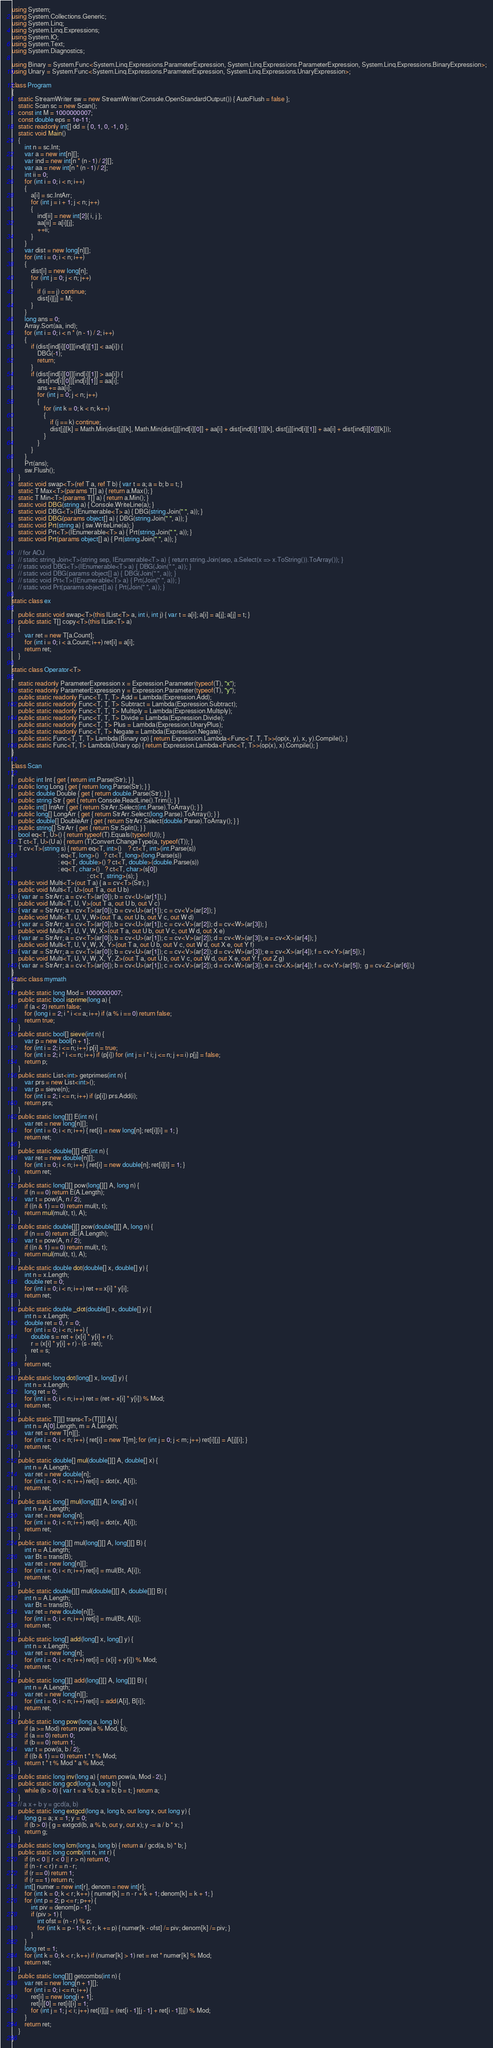<code> <loc_0><loc_0><loc_500><loc_500><_C#_>using System;
using System.Collections.Generic;
using System.Linq;
using System.Linq.Expressions;
using System.IO;
using System.Text;
using System.Diagnostics;

using Binary = System.Func<System.Linq.Expressions.ParameterExpression, System.Linq.Expressions.ParameterExpression, System.Linq.Expressions.BinaryExpression>;
using Unary = System.Func<System.Linq.Expressions.ParameterExpression, System.Linq.Expressions.UnaryExpression>;

class Program
{
    static StreamWriter sw = new StreamWriter(Console.OpenStandardOutput()) { AutoFlush = false };
    static Scan sc = new Scan();
    const int M = 1000000007;
    const double eps = 1e-11;
    static readonly int[] dd = { 0, 1, 0, -1, 0 };
    static void Main()
    {
        int n = sc.Int;
        var a = new int[n][];
        var ind = new int[n * (n - 1) / 2][];
        var aa = new int[n * (n - 1) / 2];
        int ii = 0;
        for (int i = 0; i < n; i++)
        {
            a[i] = sc.IntArr;
            for (int j = i + 1; j < n; j++)
            {
                ind[ii] = new int[2]{ i, j };
                aa[ii] = a[i][j];
                ++ii;
            }
        }
        var dist = new long[n][];
        for (int i = 0; i < n; i++)
        {
            dist[i] = new long[n];
            for (int j = 0; j < n; j++)
            {
                if (i == j) continue;
                dist[i][j] = M;
            }
        }
        long ans = 0;
        Array.Sort(aa, ind);
        for (int i = 0; i < n * (n - 1) / 2; i++)
        {
            if (dist[ind[i][0]][ind[i][1]] < aa[i]) {
                DBG(-1);
                return;
            }
            if (dist[ind[i][0]][ind[i][1]] > aa[i]) {
                dist[ind[i][0]][ind[i][1]] = aa[i];
                ans += aa[i];
                for (int j = 0; j < n; j++)
                {
                    for (int k = 0; k < n; k++)
                    {
                        if (j == k) continue;
                        dist[j][k] = Math.Min(dist[j][k], Math.Min(dist[j][ind[i][0]] + aa[i] + dist[ind[i][1]][k], dist[j][ind[i][1]] + aa[i] + dist[ind[i][0]][k]));
                    }
                }
            }
        }
        Prt(ans);
        sw.Flush();
    }
    static void swap<T>(ref T a, ref T b) { var t = a; a = b; b = t; }
    static T Max<T>(params T[] a) { return a.Max(); }
    static T Min<T>(params T[] a) { return a.Min(); }
    static void DBG(string a) { Console.WriteLine(a); }
    static void DBG<T>(IEnumerable<T> a) { DBG(string.Join(" ", a)); }
    static void DBG(params object[] a) { DBG(string.Join(" ", a)); }
    static void Prt(string a) { sw.WriteLine(a); }
    static void Prt<T>(IEnumerable<T> a) { Prt(string.Join(" ", a)); }
    static void Prt(params object[] a) { Prt(string.Join(" ", a)); }

    // for AOJ
    // static string Join<T>(string sep, IEnumerable<T> a) { return string.Join(sep, a.Select(x => x.ToString()).ToArray()); }
    // static void DBG<T>(IEnumerable<T> a) { DBG(Join(" ", a)); }
    // static void DBG(params object[] a) { DBG(Join(" ", a)); }
    // static void Prt<T>(IEnumerable<T> a) { Prt(Join(" ", a)); }
    // static void Prt(params object[] a) { Prt(Join(" ", a)); }
}
static class ex
{
    public static void swap<T>(this IList<T> a, int i, int j) { var t = a[i]; a[i] = a[j]; a[j] = t; }
    public static T[] copy<T>(this IList<T> a)
    {
        var ret = new T[a.Count];
        for (int i = 0; i < a.Count; i++) ret[i] = a[i];
        return ret;
    }
}
static class Operator<T>
{
    static readonly ParameterExpression x = Expression.Parameter(typeof(T), "x");
    static readonly ParameterExpression y = Expression.Parameter(typeof(T), "y");
    public static readonly Func<T, T, T> Add = Lambda(Expression.Add);
    public static readonly Func<T, T, T> Subtract = Lambda(Expression.Subtract);
    public static readonly Func<T, T, T> Multiply = Lambda(Expression.Multiply);
    public static readonly Func<T, T, T> Divide = Lambda(Expression.Divide);
    public static readonly Func<T, T> Plus = Lambda(Expression.UnaryPlus);
    public static readonly Func<T, T> Negate = Lambda(Expression.Negate);
    public static Func<T, T, T> Lambda(Binary op) { return Expression.Lambda<Func<T, T, T>>(op(x, y), x, y).Compile(); }
    public static Func<T, T> Lambda(Unary op) { return Expression.Lambda<Func<T, T>>(op(x), x).Compile(); }
}

class Scan
{
    public int Int { get { return int.Parse(Str); } }
    public long Long { get { return long.Parse(Str); } }
    public double Double { get { return double.Parse(Str); } }
    public string Str { get { return Console.ReadLine().Trim(); } }
    public int[] IntArr { get { return StrArr.Select(int.Parse).ToArray(); } }
    public long[] LongArr { get { return StrArr.Select(long.Parse).ToArray(); } }
    public double[] DoubleArr { get { return StrArr.Select(double.Parse).ToArray(); } }
    public string[] StrArr { get { return Str.Split(); } }
    bool eq<T, U>() { return typeof(T).Equals(typeof(U)); }
    T ct<T, U>(U a) { return (T)Convert.ChangeType(a, typeof(T)); }
    T cv<T>(string s) { return eq<T, int>()    ? ct<T, int>(int.Parse(s))
                             : eq<T, long>()   ? ct<T, long>(long.Parse(s))
                             : eq<T, double>() ? ct<T, double>(double.Parse(s))
                             : eq<T, char>()   ? ct<T, char>(s[0])
                                               : ct<T, string>(s); }
    public void Multi<T>(out T a) { a = cv<T>(Str); }
    public void Multi<T, U>(out T a, out U b)
    { var ar = StrArr; a = cv<T>(ar[0]); b = cv<U>(ar[1]); }
    public void Multi<T, U, V>(out T a, out U b, out V c)
    { var ar = StrArr; a = cv<T>(ar[0]); b = cv<U>(ar[1]); c = cv<V>(ar[2]); }
    public void Multi<T, U, V, W>(out T a, out U b, out V c, out W d)
    { var ar = StrArr; a = cv<T>(ar[0]); b = cv<U>(ar[1]); c = cv<V>(ar[2]); d = cv<W>(ar[3]); }
    public void Multi<T, U, V, W, X>(out T a, out U b, out V c, out W d, out X e)
    { var ar = StrArr; a = cv<T>(ar[0]); b = cv<U>(ar[1]); c = cv<V>(ar[2]); d = cv<W>(ar[3]); e = cv<X>(ar[4]); }
    public void Multi<T, U, V, W, X, Y>(out T a, out U b, out V c, out W d, out X e, out Y f)
    { var ar = StrArr; a = cv<T>(ar[0]); b = cv<U>(ar[1]); c = cv<V>(ar[2]); d = cv<W>(ar[3]); e = cv<X>(ar[4]); f = cv<Y>(ar[5]); }
    public void Multi<T, U, V, W, X, Y, Z>(out T a, out U b, out V c, out W d, out X e, out Y f, out Z g)
    { var ar = StrArr; a = cv<T>(ar[0]); b = cv<U>(ar[1]); c = cv<V>(ar[2]); d = cv<W>(ar[3]); e = cv<X>(ar[4]); f = cv<Y>(ar[5]);  g = cv<Z>(ar[6]);}
}
static class mymath
{
    public static long Mod = 1000000007;
    public static bool isprime(long a) {
        if (a < 2) return false;
        for (long i = 2; i * i <= a; i++) if (a % i == 0) return false;
        return true;
    }
    public static bool[] sieve(int n) {
        var p = new bool[n + 1];
        for (int i = 2; i <= n; i++) p[i] = true;
        for (int i = 2; i * i <= n; i++) if (p[i]) for (int j = i * i; j <= n; j += i) p[j] = false;
        return p;
    }
    public static List<int> getprimes(int n) {
        var prs = new List<int>();
        var p = sieve(n);
        for (int i = 2; i <= n; i++) if (p[i]) prs.Add(i);
        return prs;
    }
    public static long[][] E(int n) {
        var ret = new long[n][];
        for (int i = 0; i < n; i++) { ret[i] = new long[n]; ret[i][i] = 1; }
        return ret;
    }
    public static double[][] dE(int n) {
        var ret = new double[n][];
        for (int i = 0; i < n; i++) { ret[i] = new double[n]; ret[i][i] = 1; }
        return ret;
    }
    public static long[][] pow(long[][] A, long n) {
        if (n == 0) return E(A.Length);
        var t = pow(A, n / 2);
        if ((n & 1) == 0) return mul(t, t);
        return mul(mul(t, t), A);
    }
    public static double[][] pow(double[][] A, long n) {
        if (n == 0) return dE(A.Length);
        var t = pow(A, n / 2);
        if ((n & 1) == 0) return mul(t, t);
        return mul(mul(t, t), A);
    }
    public static double dot(double[] x, double[] y) {
        int n = x.Length;
        double ret = 0;
        for (int i = 0; i < n; i++) ret += x[i] * y[i];
        return ret;
    }
    public static double _dot(double[] x, double[] y) {
        int n = x.Length;
        double ret = 0, r = 0;
        for (int i = 0; i < n; i++) {
            double s = ret + (x[i] * y[i] + r);
            r = (x[i] * y[i] + r) - (s - ret);
            ret = s;
        }
        return ret;
    }
    public static long dot(long[] x, long[] y) {
        int n = x.Length;
        long ret = 0;
        for (int i = 0; i < n; i++) ret = (ret + x[i] * y[i]) % Mod;
        return ret;
    }
    public static T[][] trans<T>(T[][] A) {
        int n = A[0].Length, m = A.Length;
        var ret = new T[n][];
        for (int i = 0; i < n; i++) { ret[i] = new T[m]; for (int j = 0; j < m; j++) ret[i][j] = A[j][i]; }
        return ret;
    }
    public static double[] mul(double[][] A, double[] x) {
        int n = A.Length;
        var ret = new double[n];
        for (int i = 0; i < n; i++) ret[i] = dot(x, A[i]);
        return ret;
    }
    public static long[] mul(long[][] A, long[] x) {
        int n = A.Length;
        var ret = new long[n];
        for (int i = 0; i < n; i++) ret[i] = dot(x, A[i]);
        return ret;
    }
    public static long[][] mul(long[][] A, long[][] B) {
        int n = A.Length;
        var Bt = trans(B);
        var ret = new long[n][];
        for (int i = 0; i < n; i++) ret[i] = mul(Bt, A[i]);
        return ret;
    }
    public static double[][] mul(double[][] A, double[][] B) {
        int n = A.Length;
        var Bt = trans(B);
        var ret = new double[n][];
        for (int i = 0; i < n; i++) ret[i] = mul(Bt, A[i]);
        return ret;
    }
    public static long[] add(long[] x, long[] y) {
        int n = x.Length;
        var ret = new long[n];
        for (int i = 0; i < n; i++) ret[i] = (x[i] + y[i]) % Mod;
        return ret;
    }
    public static long[][] add(long[][] A, long[][] B) {
        int n = A.Length;
        var ret = new long[n][];
        for (int i = 0; i < n; i++) ret[i] = add(A[i], B[i]);
        return ret;
    }
    public static long pow(long a, long b) {
        if (a >= Mod) return pow(a % Mod, b);
        if (a == 0) return 0;
        if (b == 0) return 1;
        var t = pow(a, b / 2);
        if ((b & 1) == 0) return t * t % Mod;
        return t * t % Mod * a % Mod;
    }
    public static long inv(long a) { return pow(a, Mod - 2); }
    public static long gcd(long a, long b) {
        while (b > 0) { var t = a % b; a = b; b = t; } return a;
    }
    // a x + b y = gcd(a, b)
    public static long extgcd(long a, long b, out long x, out long y) {
        long g = a; x = 1; y = 0;
        if (b > 0) { g = extgcd(b, a % b, out y, out x); y -= a / b * x; }
        return g;
    }
    public static long lcm(long a, long b) { return a / gcd(a, b) * b; }
    public static long comb(int n, int r) {
        if (n < 0 || r < 0 || r > n) return 0;
        if (n - r < r) r = n - r;
        if (r == 0) return 1;
        if (r == 1) return n;
        int[] numer = new int[r], denom = new int[r];
        for (int k = 0; k < r; k++) { numer[k] = n - r + k + 1; denom[k] = k + 1; }
        for (int p = 2; p <= r; p++) {
            int piv = denom[p - 1];
            if (piv > 1) {
                int ofst = (n - r) % p;
                for (int k = p - 1; k < r; k += p) { numer[k - ofst] /= piv; denom[k] /= piv; }
            }
        }
        long ret = 1;
        for (int k = 0; k < r; k++) if (numer[k] > 1) ret = ret * numer[k] % Mod;
        return ret;
    }
    public static long[][] getcombs(int n) {
        var ret = new long[n + 1][];
        for (int i = 0; i <= n; i++) {
            ret[i] = new long[i + 1];
            ret[i][0] = ret[i][i] = 1;
            for (int j = 1; j < i; j++) ret[i][j] = (ret[i - 1][j - 1] + ret[i - 1][j]) % Mod;
        }
        return ret;
    }
}
</code> 